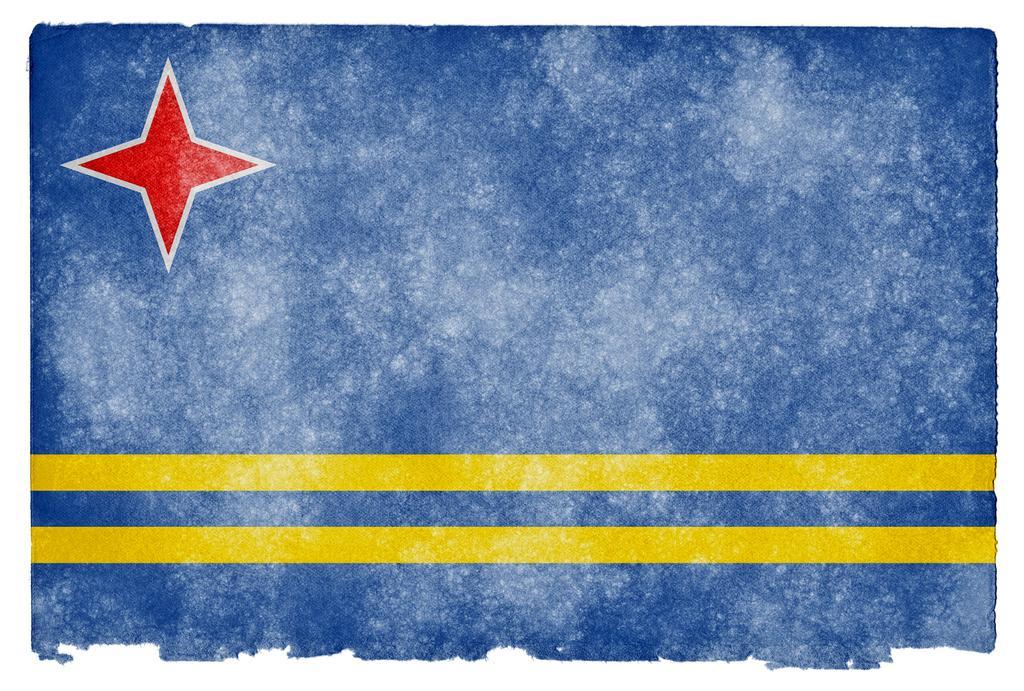In one or two sentences, can you explain what this image depicts? In this image there are two yellow colored parallel lines and a red colored star on a blue colored background. 